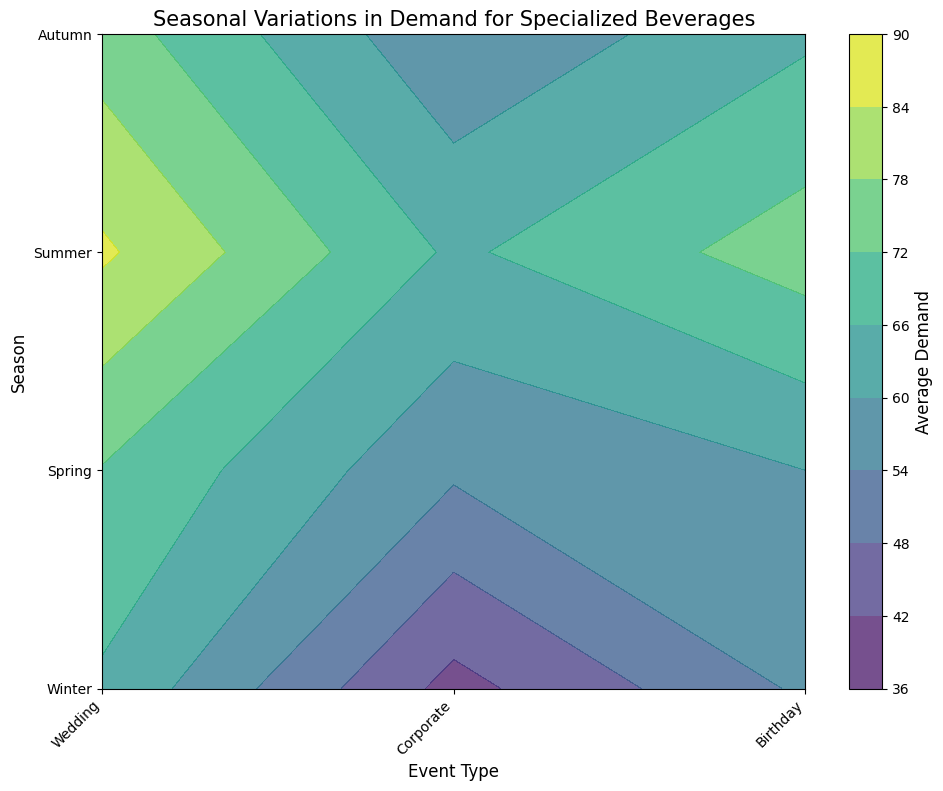Which season has the highest average demand for beverages at weddings? To find the season with the highest average demand for weddings, look for the darkest (deepest color) area in the contour plot on the 'Wedding' column. The darkest area in the 'Wedding' column corresponds to 'Summer'.
Answer: Summer How does the average demand for beverages at corporate events in winter compare to autumn? Compare the color gradients for 'Corporate' events in both 'Winter' and 'Autumn'. The lighter the shade, the lower the demand. 'Winter' has a lighter shade than 'Autumn', indicating that the average demand in 'Winter' is lower.
Answer: Lower Which event type has the lowest average demand in spring? Look for the lightest area in the 'Spring' row. The lightest area corresponds to 'Corporate' events.
Answer: Corporate Is the demand for beverages at birthdays higher in summer than in winter? Compare the color gradients in the 'Birthday' column for both 'Summer' and 'Winter'. The 'Birthday' column in 'Summer' is darker than in 'Winter', indicating a higher demand.
Answer: Higher Which season and event type combination has the highest average demand for beverages? Locate the darkest area in the entire contour plot. The combination of 'Wedding' events in 'Summer' has the darkest color, representing the highest average demand.
Answer: Summer-Wedding What is the average demand difference between corporate events in spring and fall? Compare the color gradients for 'Corporate' events in 'Spring' and 'Autumn' rows. The color for 'Spring' is slightly lighter than 'Autumn', indicating 'Autumn' has a higher demand. If necessary, calculate the difference using their average demand values (55 for Spring, 55 for Autumn).
Answer: 0 What visual cue indicates the variability of beverage demand across different seasons at weddings? Notice the variation in color gradients in the 'Wedding' column across different seasons. The stark contrasts in shades from 'Winter' to 'Summer' reveal significant differences in demand.
Answer: The color gradients Which type of event shows the most consistent demand across all seasons? Look for the column with the most uniform color gradient across all rows (seasons). The 'Corporate' column maintains a relatively consistent shade, indicating stable demand.
Answer: Corporate During which season is the demand for beverages at birthday events the highest, based on the contour’s coloring? Examine the 'Birthday' column for the darkest area across different rows (seasons). The darkest area is seen in the 'Summer' row, indicating the highest demand.
Answer: Summer 